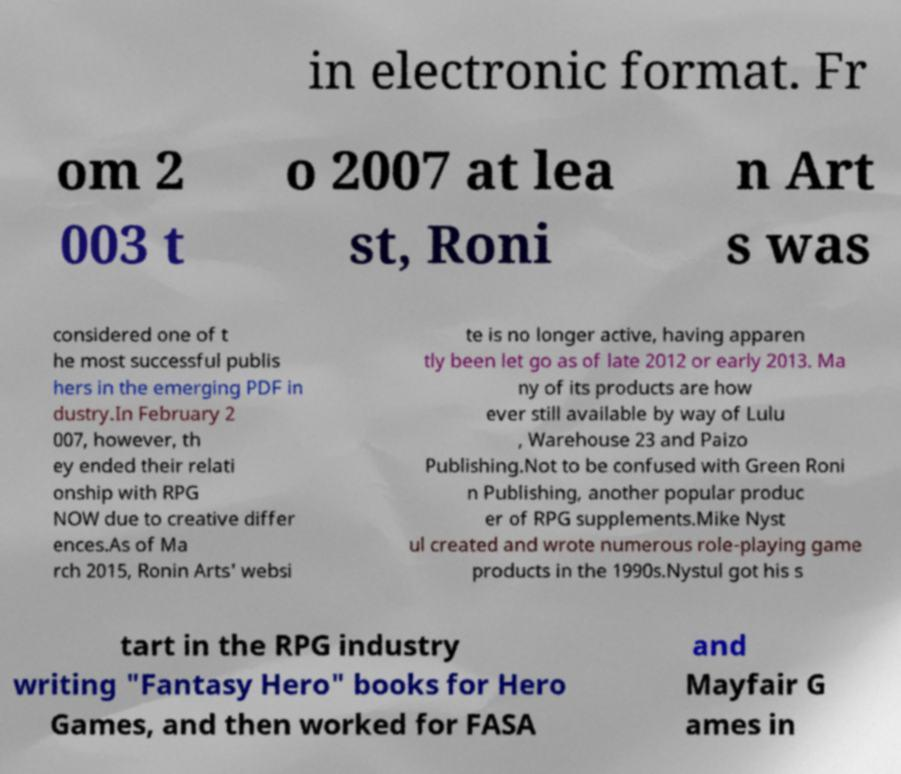I need the written content from this picture converted into text. Can you do that? in electronic format. Fr om 2 003 t o 2007 at lea st, Roni n Art s was considered one of t he most successful publis hers in the emerging PDF in dustry.In February 2 007, however, th ey ended their relati onship with RPG NOW due to creative differ ences.As of Ma rch 2015, Ronin Arts' websi te is no longer active, having apparen tly been let go as of late 2012 or early 2013. Ma ny of its products are how ever still available by way of Lulu , Warehouse 23 and Paizo Publishing.Not to be confused with Green Roni n Publishing, another popular produc er of RPG supplements.Mike Nyst ul created and wrote numerous role-playing game products in the 1990s.Nystul got his s tart in the RPG industry writing "Fantasy Hero" books for Hero Games, and then worked for FASA and Mayfair G ames in 